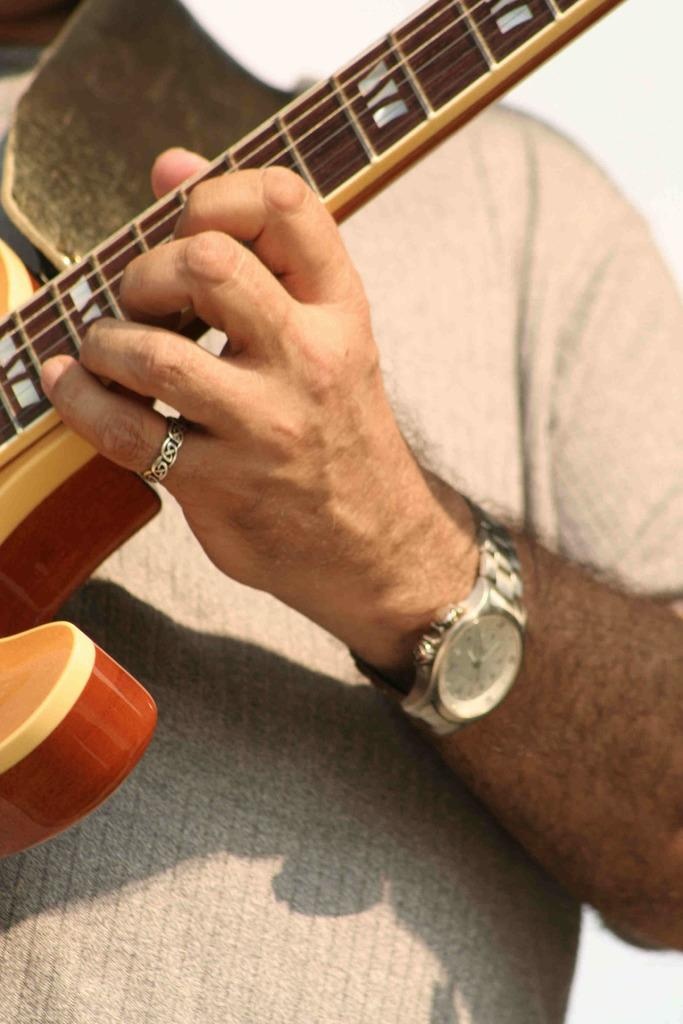Who is present in the image? There is a man in the image. What is the man holding in the image? The man is holding a guitar. Can you identify any accessories the man is wearing in the image? Yes, there is a wristwatch visible in the image. What type of feather can be seen in the image? There is no feather present in the image. How much does the mass of the guitar weigh in the image? The weight of the guitar cannot be determined from the image alone, as it is a visual representation and not a physical object. 